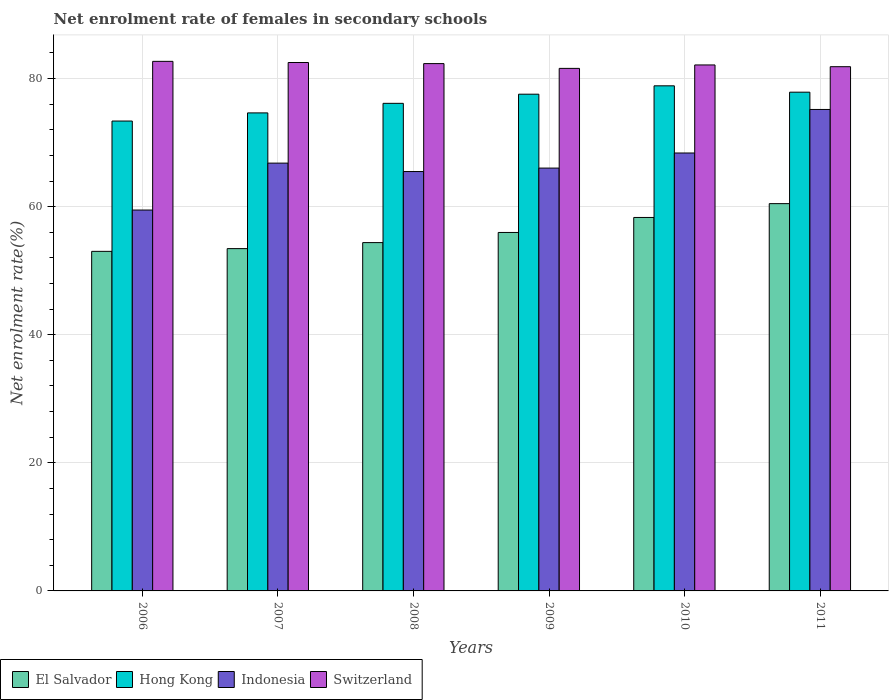How many different coloured bars are there?
Your answer should be compact. 4. How many bars are there on the 5th tick from the right?
Give a very brief answer. 4. What is the label of the 6th group of bars from the left?
Your answer should be very brief. 2011. In how many cases, is the number of bars for a given year not equal to the number of legend labels?
Make the answer very short. 0. What is the net enrolment rate of females in secondary schools in El Salvador in 2008?
Provide a succinct answer. 54.39. Across all years, what is the maximum net enrolment rate of females in secondary schools in El Salvador?
Give a very brief answer. 60.47. Across all years, what is the minimum net enrolment rate of females in secondary schools in Hong Kong?
Offer a terse response. 73.37. In which year was the net enrolment rate of females in secondary schools in Switzerland maximum?
Your answer should be very brief. 2006. In which year was the net enrolment rate of females in secondary schools in El Salvador minimum?
Your answer should be compact. 2006. What is the total net enrolment rate of females in secondary schools in Switzerland in the graph?
Ensure brevity in your answer.  493.08. What is the difference between the net enrolment rate of females in secondary schools in El Salvador in 2009 and that in 2011?
Provide a succinct answer. -4.5. What is the difference between the net enrolment rate of females in secondary schools in El Salvador in 2007 and the net enrolment rate of females in secondary schools in Hong Kong in 2009?
Your answer should be very brief. -24.11. What is the average net enrolment rate of females in secondary schools in Switzerland per year?
Offer a terse response. 82.18. In the year 2007, what is the difference between the net enrolment rate of females in secondary schools in Switzerland and net enrolment rate of females in secondary schools in El Salvador?
Offer a very short reply. 29.06. What is the ratio of the net enrolment rate of females in secondary schools in Indonesia in 2009 to that in 2010?
Your answer should be compact. 0.97. Is the net enrolment rate of females in secondary schools in Hong Kong in 2006 less than that in 2010?
Make the answer very short. Yes. What is the difference between the highest and the second highest net enrolment rate of females in secondary schools in Hong Kong?
Your answer should be compact. 0.99. What is the difference between the highest and the lowest net enrolment rate of females in secondary schools in Hong Kong?
Your answer should be compact. 5.5. In how many years, is the net enrolment rate of females in secondary schools in Switzerland greater than the average net enrolment rate of females in secondary schools in Switzerland taken over all years?
Your response must be concise. 3. Is the sum of the net enrolment rate of females in secondary schools in Hong Kong in 2006 and 2011 greater than the maximum net enrolment rate of females in secondary schools in Indonesia across all years?
Your answer should be compact. Yes. Is it the case that in every year, the sum of the net enrolment rate of females in secondary schools in Indonesia and net enrolment rate of females in secondary schools in Hong Kong is greater than the sum of net enrolment rate of females in secondary schools in Switzerland and net enrolment rate of females in secondary schools in El Salvador?
Keep it short and to the point. Yes. What does the 1st bar from the right in 2007 represents?
Offer a terse response. Switzerland. How many bars are there?
Ensure brevity in your answer.  24. Are all the bars in the graph horizontal?
Ensure brevity in your answer.  No. What is the difference between two consecutive major ticks on the Y-axis?
Provide a succinct answer. 20. Are the values on the major ticks of Y-axis written in scientific E-notation?
Your answer should be very brief. No. Does the graph contain any zero values?
Provide a succinct answer. No. Does the graph contain grids?
Ensure brevity in your answer.  Yes. What is the title of the graph?
Provide a short and direct response. Net enrolment rate of females in secondary schools. What is the label or title of the X-axis?
Your answer should be compact. Years. What is the label or title of the Y-axis?
Keep it short and to the point. Net enrolment rate(%). What is the Net enrolment rate(%) of El Salvador in 2006?
Your answer should be compact. 53.02. What is the Net enrolment rate(%) of Hong Kong in 2006?
Offer a terse response. 73.37. What is the Net enrolment rate(%) in Indonesia in 2006?
Provide a short and direct response. 59.47. What is the Net enrolment rate(%) in Switzerland in 2006?
Your answer should be very brief. 82.68. What is the Net enrolment rate(%) in El Salvador in 2007?
Provide a succinct answer. 53.44. What is the Net enrolment rate(%) in Hong Kong in 2007?
Your response must be concise. 74.64. What is the Net enrolment rate(%) in Indonesia in 2007?
Your response must be concise. 66.79. What is the Net enrolment rate(%) of Switzerland in 2007?
Your answer should be very brief. 82.5. What is the Net enrolment rate(%) in El Salvador in 2008?
Give a very brief answer. 54.39. What is the Net enrolment rate(%) of Hong Kong in 2008?
Offer a terse response. 76.13. What is the Net enrolment rate(%) in Indonesia in 2008?
Provide a short and direct response. 65.48. What is the Net enrolment rate(%) in Switzerland in 2008?
Your answer should be compact. 82.33. What is the Net enrolment rate(%) of El Salvador in 2009?
Your response must be concise. 55.97. What is the Net enrolment rate(%) in Hong Kong in 2009?
Offer a terse response. 77.56. What is the Net enrolment rate(%) of Indonesia in 2009?
Your answer should be very brief. 66.02. What is the Net enrolment rate(%) of Switzerland in 2009?
Offer a very short reply. 81.59. What is the Net enrolment rate(%) in El Salvador in 2010?
Provide a succinct answer. 58.31. What is the Net enrolment rate(%) of Hong Kong in 2010?
Offer a terse response. 78.86. What is the Net enrolment rate(%) in Indonesia in 2010?
Offer a very short reply. 68.38. What is the Net enrolment rate(%) of Switzerland in 2010?
Provide a short and direct response. 82.12. What is the Net enrolment rate(%) in El Salvador in 2011?
Ensure brevity in your answer.  60.47. What is the Net enrolment rate(%) of Hong Kong in 2011?
Your answer should be very brief. 77.87. What is the Net enrolment rate(%) of Indonesia in 2011?
Your answer should be compact. 75.17. What is the Net enrolment rate(%) in Switzerland in 2011?
Your response must be concise. 81.85. Across all years, what is the maximum Net enrolment rate(%) of El Salvador?
Offer a terse response. 60.47. Across all years, what is the maximum Net enrolment rate(%) of Hong Kong?
Offer a terse response. 78.86. Across all years, what is the maximum Net enrolment rate(%) in Indonesia?
Make the answer very short. 75.17. Across all years, what is the maximum Net enrolment rate(%) in Switzerland?
Give a very brief answer. 82.68. Across all years, what is the minimum Net enrolment rate(%) in El Salvador?
Your answer should be compact. 53.02. Across all years, what is the minimum Net enrolment rate(%) in Hong Kong?
Give a very brief answer. 73.37. Across all years, what is the minimum Net enrolment rate(%) in Indonesia?
Your answer should be very brief. 59.47. Across all years, what is the minimum Net enrolment rate(%) in Switzerland?
Give a very brief answer. 81.59. What is the total Net enrolment rate(%) in El Salvador in the graph?
Keep it short and to the point. 335.6. What is the total Net enrolment rate(%) of Hong Kong in the graph?
Your answer should be very brief. 458.43. What is the total Net enrolment rate(%) of Indonesia in the graph?
Your answer should be compact. 401.31. What is the total Net enrolment rate(%) of Switzerland in the graph?
Provide a short and direct response. 493.08. What is the difference between the Net enrolment rate(%) in El Salvador in 2006 and that in 2007?
Your answer should be compact. -0.42. What is the difference between the Net enrolment rate(%) of Hong Kong in 2006 and that in 2007?
Give a very brief answer. -1.27. What is the difference between the Net enrolment rate(%) in Indonesia in 2006 and that in 2007?
Offer a very short reply. -7.32. What is the difference between the Net enrolment rate(%) in Switzerland in 2006 and that in 2007?
Your answer should be compact. 0.18. What is the difference between the Net enrolment rate(%) of El Salvador in 2006 and that in 2008?
Ensure brevity in your answer.  -1.37. What is the difference between the Net enrolment rate(%) of Hong Kong in 2006 and that in 2008?
Provide a succinct answer. -2.76. What is the difference between the Net enrolment rate(%) in Indonesia in 2006 and that in 2008?
Your answer should be compact. -6.01. What is the difference between the Net enrolment rate(%) of Switzerland in 2006 and that in 2008?
Keep it short and to the point. 0.35. What is the difference between the Net enrolment rate(%) in El Salvador in 2006 and that in 2009?
Provide a short and direct response. -2.95. What is the difference between the Net enrolment rate(%) in Hong Kong in 2006 and that in 2009?
Your response must be concise. -4.19. What is the difference between the Net enrolment rate(%) in Indonesia in 2006 and that in 2009?
Offer a terse response. -6.55. What is the difference between the Net enrolment rate(%) in Switzerland in 2006 and that in 2009?
Provide a succinct answer. 1.1. What is the difference between the Net enrolment rate(%) of El Salvador in 2006 and that in 2010?
Offer a very short reply. -5.29. What is the difference between the Net enrolment rate(%) in Hong Kong in 2006 and that in 2010?
Your answer should be very brief. -5.5. What is the difference between the Net enrolment rate(%) of Indonesia in 2006 and that in 2010?
Give a very brief answer. -8.91. What is the difference between the Net enrolment rate(%) in Switzerland in 2006 and that in 2010?
Ensure brevity in your answer.  0.56. What is the difference between the Net enrolment rate(%) in El Salvador in 2006 and that in 2011?
Offer a terse response. -7.45. What is the difference between the Net enrolment rate(%) of Hong Kong in 2006 and that in 2011?
Your answer should be very brief. -4.5. What is the difference between the Net enrolment rate(%) of Indonesia in 2006 and that in 2011?
Your answer should be compact. -15.7. What is the difference between the Net enrolment rate(%) of Switzerland in 2006 and that in 2011?
Give a very brief answer. 0.83. What is the difference between the Net enrolment rate(%) in El Salvador in 2007 and that in 2008?
Give a very brief answer. -0.94. What is the difference between the Net enrolment rate(%) in Hong Kong in 2007 and that in 2008?
Make the answer very short. -1.49. What is the difference between the Net enrolment rate(%) in Indonesia in 2007 and that in 2008?
Make the answer very short. 1.31. What is the difference between the Net enrolment rate(%) in Switzerland in 2007 and that in 2008?
Offer a very short reply. 0.17. What is the difference between the Net enrolment rate(%) of El Salvador in 2007 and that in 2009?
Provide a short and direct response. -2.52. What is the difference between the Net enrolment rate(%) in Hong Kong in 2007 and that in 2009?
Make the answer very short. -2.92. What is the difference between the Net enrolment rate(%) of Indonesia in 2007 and that in 2009?
Offer a terse response. 0.78. What is the difference between the Net enrolment rate(%) in Switzerland in 2007 and that in 2009?
Make the answer very short. 0.92. What is the difference between the Net enrolment rate(%) of El Salvador in 2007 and that in 2010?
Keep it short and to the point. -4.87. What is the difference between the Net enrolment rate(%) of Hong Kong in 2007 and that in 2010?
Offer a very short reply. -4.23. What is the difference between the Net enrolment rate(%) of Indonesia in 2007 and that in 2010?
Offer a terse response. -1.58. What is the difference between the Net enrolment rate(%) of Switzerland in 2007 and that in 2010?
Make the answer very short. 0.38. What is the difference between the Net enrolment rate(%) in El Salvador in 2007 and that in 2011?
Keep it short and to the point. -7.02. What is the difference between the Net enrolment rate(%) in Hong Kong in 2007 and that in 2011?
Your answer should be compact. -3.23. What is the difference between the Net enrolment rate(%) in Indonesia in 2007 and that in 2011?
Offer a terse response. -8.38. What is the difference between the Net enrolment rate(%) of Switzerland in 2007 and that in 2011?
Offer a very short reply. 0.65. What is the difference between the Net enrolment rate(%) of El Salvador in 2008 and that in 2009?
Provide a short and direct response. -1.58. What is the difference between the Net enrolment rate(%) of Hong Kong in 2008 and that in 2009?
Your answer should be very brief. -1.43. What is the difference between the Net enrolment rate(%) of Indonesia in 2008 and that in 2009?
Your answer should be very brief. -0.54. What is the difference between the Net enrolment rate(%) in Switzerland in 2008 and that in 2009?
Your response must be concise. 0.75. What is the difference between the Net enrolment rate(%) of El Salvador in 2008 and that in 2010?
Your answer should be compact. -3.92. What is the difference between the Net enrolment rate(%) in Hong Kong in 2008 and that in 2010?
Provide a succinct answer. -2.73. What is the difference between the Net enrolment rate(%) in Indonesia in 2008 and that in 2010?
Your answer should be compact. -2.9. What is the difference between the Net enrolment rate(%) in Switzerland in 2008 and that in 2010?
Give a very brief answer. 0.21. What is the difference between the Net enrolment rate(%) of El Salvador in 2008 and that in 2011?
Give a very brief answer. -6.08. What is the difference between the Net enrolment rate(%) in Hong Kong in 2008 and that in 2011?
Provide a succinct answer. -1.74. What is the difference between the Net enrolment rate(%) of Indonesia in 2008 and that in 2011?
Keep it short and to the point. -9.69. What is the difference between the Net enrolment rate(%) of Switzerland in 2008 and that in 2011?
Give a very brief answer. 0.48. What is the difference between the Net enrolment rate(%) of El Salvador in 2009 and that in 2010?
Give a very brief answer. -2.34. What is the difference between the Net enrolment rate(%) in Hong Kong in 2009 and that in 2010?
Make the answer very short. -1.31. What is the difference between the Net enrolment rate(%) in Indonesia in 2009 and that in 2010?
Offer a very short reply. -2.36. What is the difference between the Net enrolment rate(%) of Switzerland in 2009 and that in 2010?
Your response must be concise. -0.54. What is the difference between the Net enrolment rate(%) in El Salvador in 2009 and that in 2011?
Your answer should be compact. -4.5. What is the difference between the Net enrolment rate(%) in Hong Kong in 2009 and that in 2011?
Make the answer very short. -0.31. What is the difference between the Net enrolment rate(%) in Indonesia in 2009 and that in 2011?
Keep it short and to the point. -9.15. What is the difference between the Net enrolment rate(%) in Switzerland in 2009 and that in 2011?
Keep it short and to the point. -0.26. What is the difference between the Net enrolment rate(%) of El Salvador in 2010 and that in 2011?
Your answer should be compact. -2.16. What is the difference between the Net enrolment rate(%) of Hong Kong in 2010 and that in 2011?
Your answer should be very brief. 0.99. What is the difference between the Net enrolment rate(%) of Indonesia in 2010 and that in 2011?
Your response must be concise. -6.8. What is the difference between the Net enrolment rate(%) of Switzerland in 2010 and that in 2011?
Ensure brevity in your answer.  0.27. What is the difference between the Net enrolment rate(%) of El Salvador in 2006 and the Net enrolment rate(%) of Hong Kong in 2007?
Ensure brevity in your answer.  -21.62. What is the difference between the Net enrolment rate(%) of El Salvador in 2006 and the Net enrolment rate(%) of Indonesia in 2007?
Ensure brevity in your answer.  -13.77. What is the difference between the Net enrolment rate(%) of El Salvador in 2006 and the Net enrolment rate(%) of Switzerland in 2007?
Your answer should be very brief. -29.48. What is the difference between the Net enrolment rate(%) of Hong Kong in 2006 and the Net enrolment rate(%) of Indonesia in 2007?
Keep it short and to the point. 6.57. What is the difference between the Net enrolment rate(%) in Hong Kong in 2006 and the Net enrolment rate(%) in Switzerland in 2007?
Keep it short and to the point. -9.14. What is the difference between the Net enrolment rate(%) in Indonesia in 2006 and the Net enrolment rate(%) in Switzerland in 2007?
Provide a succinct answer. -23.03. What is the difference between the Net enrolment rate(%) in El Salvador in 2006 and the Net enrolment rate(%) in Hong Kong in 2008?
Offer a very short reply. -23.11. What is the difference between the Net enrolment rate(%) of El Salvador in 2006 and the Net enrolment rate(%) of Indonesia in 2008?
Your response must be concise. -12.46. What is the difference between the Net enrolment rate(%) of El Salvador in 2006 and the Net enrolment rate(%) of Switzerland in 2008?
Your response must be concise. -29.31. What is the difference between the Net enrolment rate(%) of Hong Kong in 2006 and the Net enrolment rate(%) of Indonesia in 2008?
Keep it short and to the point. 7.89. What is the difference between the Net enrolment rate(%) of Hong Kong in 2006 and the Net enrolment rate(%) of Switzerland in 2008?
Offer a terse response. -8.97. What is the difference between the Net enrolment rate(%) of Indonesia in 2006 and the Net enrolment rate(%) of Switzerland in 2008?
Offer a very short reply. -22.86. What is the difference between the Net enrolment rate(%) of El Salvador in 2006 and the Net enrolment rate(%) of Hong Kong in 2009?
Provide a short and direct response. -24.54. What is the difference between the Net enrolment rate(%) in El Salvador in 2006 and the Net enrolment rate(%) in Indonesia in 2009?
Offer a very short reply. -13. What is the difference between the Net enrolment rate(%) in El Salvador in 2006 and the Net enrolment rate(%) in Switzerland in 2009?
Ensure brevity in your answer.  -28.57. What is the difference between the Net enrolment rate(%) in Hong Kong in 2006 and the Net enrolment rate(%) in Indonesia in 2009?
Offer a very short reply. 7.35. What is the difference between the Net enrolment rate(%) of Hong Kong in 2006 and the Net enrolment rate(%) of Switzerland in 2009?
Provide a succinct answer. -8.22. What is the difference between the Net enrolment rate(%) of Indonesia in 2006 and the Net enrolment rate(%) of Switzerland in 2009?
Give a very brief answer. -22.12. What is the difference between the Net enrolment rate(%) of El Salvador in 2006 and the Net enrolment rate(%) of Hong Kong in 2010?
Your response must be concise. -25.84. What is the difference between the Net enrolment rate(%) of El Salvador in 2006 and the Net enrolment rate(%) of Indonesia in 2010?
Give a very brief answer. -15.36. What is the difference between the Net enrolment rate(%) of El Salvador in 2006 and the Net enrolment rate(%) of Switzerland in 2010?
Provide a succinct answer. -29.1. What is the difference between the Net enrolment rate(%) in Hong Kong in 2006 and the Net enrolment rate(%) in Indonesia in 2010?
Your answer should be compact. 4.99. What is the difference between the Net enrolment rate(%) of Hong Kong in 2006 and the Net enrolment rate(%) of Switzerland in 2010?
Offer a very short reply. -8.76. What is the difference between the Net enrolment rate(%) of Indonesia in 2006 and the Net enrolment rate(%) of Switzerland in 2010?
Your answer should be very brief. -22.65. What is the difference between the Net enrolment rate(%) of El Salvador in 2006 and the Net enrolment rate(%) of Hong Kong in 2011?
Keep it short and to the point. -24.85. What is the difference between the Net enrolment rate(%) of El Salvador in 2006 and the Net enrolment rate(%) of Indonesia in 2011?
Ensure brevity in your answer.  -22.15. What is the difference between the Net enrolment rate(%) in El Salvador in 2006 and the Net enrolment rate(%) in Switzerland in 2011?
Make the answer very short. -28.83. What is the difference between the Net enrolment rate(%) of Hong Kong in 2006 and the Net enrolment rate(%) of Indonesia in 2011?
Make the answer very short. -1.81. What is the difference between the Net enrolment rate(%) of Hong Kong in 2006 and the Net enrolment rate(%) of Switzerland in 2011?
Your response must be concise. -8.48. What is the difference between the Net enrolment rate(%) of Indonesia in 2006 and the Net enrolment rate(%) of Switzerland in 2011?
Your answer should be very brief. -22.38. What is the difference between the Net enrolment rate(%) in El Salvador in 2007 and the Net enrolment rate(%) in Hong Kong in 2008?
Offer a terse response. -22.68. What is the difference between the Net enrolment rate(%) of El Salvador in 2007 and the Net enrolment rate(%) of Indonesia in 2008?
Offer a terse response. -12.04. What is the difference between the Net enrolment rate(%) of El Salvador in 2007 and the Net enrolment rate(%) of Switzerland in 2008?
Your answer should be very brief. -28.89. What is the difference between the Net enrolment rate(%) of Hong Kong in 2007 and the Net enrolment rate(%) of Indonesia in 2008?
Make the answer very short. 9.16. What is the difference between the Net enrolment rate(%) in Hong Kong in 2007 and the Net enrolment rate(%) in Switzerland in 2008?
Your response must be concise. -7.7. What is the difference between the Net enrolment rate(%) in Indonesia in 2007 and the Net enrolment rate(%) in Switzerland in 2008?
Provide a succinct answer. -15.54. What is the difference between the Net enrolment rate(%) in El Salvador in 2007 and the Net enrolment rate(%) in Hong Kong in 2009?
Your answer should be compact. -24.11. What is the difference between the Net enrolment rate(%) of El Salvador in 2007 and the Net enrolment rate(%) of Indonesia in 2009?
Your answer should be very brief. -12.57. What is the difference between the Net enrolment rate(%) of El Salvador in 2007 and the Net enrolment rate(%) of Switzerland in 2009?
Ensure brevity in your answer.  -28.14. What is the difference between the Net enrolment rate(%) of Hong Kong in 2007 and the Net enrolment rate(%) of Indonesia in 2009?
Your response must be concise. 8.62. What is the difference between the Net enrolment rate(%) in Hong Kong in 2007 and the Net enrolment rate(%) in Switzerland in 2009?
Make the answer very short. -6.95. What is the difference between the Net enrolment rate(%) of Indonesia in 2007 and the Net enrolment rate(%) of Switzerland in 2009?
Ensure brevity in your answer.  -14.79. What is the difference between the Net enrolment rate(%) of El Salvador in 2007 and the Net enrolment rate(%) of Hong Kong in 2010?
Make the answer very short. -25.42. What is the difference between the Net enrolment rate(%) of El Salvador in 2007 and the Net enrolment rate(%) of Indonesia in 2010?
Your response must be concise. -14.93. What is the difference between the Net enrolment rate(%) of El Salvador in 2007 and the Net enrolment rate(%) of Switzerland in 2010?
Offer a terse response. -28.68. What is the difference between the Net enrolment rate(%) of Hong Kong in 2007 and the Net enrolment rate(%) of Indonesia in 2010?
Offer a very short reply. 6.26. What is the difference between the Net enrolment rate(%) of Hong Kong in 2007 and the Net enrolment rate(%) of Switzerland in 2010?
Provide a succinct answer. -7.49. What is the difference between the Net enrolment rate(%) of Indonesia in 2007 and the Net enrolment rate(%) of Switzerland in 2010?
Your answer should be compact. -15.33. What is the difference between the Net enrolment rate(%) in El Salvador in 2007 and the Net enrolment rate(%) in Hong Kong in 2011?
Offer a very short reply. -24.43. What is the difference between the Net enrolment rate(%) in El Salvador in 2007 and the Net enrolment rate(%) in Indonesia in 2011?
Offer a terse response. -21.73. What is the difference between the Net enrolment rate(%) of El Salvador in 2007 and the Net enrolment rate(%) of Switzerland in 2011?
Offer a very short reply. -28.41. What is the difference between the Net enrolment rate(%) of Hong Kong in 2007 and the Net enrolment rate(%) of Indonesia in 2011?
Your answer should be compact. -0.54. What is the difference between the Net enrolment rate(%) in Hong Kong in 2007 and the Net enrolment rate(%) in Switzerland in 2011?
Give a very brief answer. -7.21. What is the difference between the Net enrolment rate(%) in Indonesia in 2007 and the Net enrolment rate(%) in Switzerland in 2011?
Your answer should be very brief. -15.06. What is the difference between the Net enrolment rate(%) of El Salvador in 2008 and the Net enrolment rate(%) of Hong Kong in 2009?
Your answer should be very brief. -23.17. What is the difference between the Net enrolment rate(%) in El Salvador in 2008 and the Net enrolment rate(%) in Indonesia in 2009?
Your answer should be very brief. -11.63. What is the difference between the Net enrolment rate(%) in El Salvador in 2008 and the Net enrolment rate(%) in Switzerland in 2009?
Provide a succinct answer. -27.2. What is the difference between the Net enrolment rate(%) in Hong Kong in 2008 and the Net enrolment rate(%) in Indonesia in 2009?
Offer a terse response. 10.11. What is the difference between the Net enrolment rate(%) in Hong Kong in 2008 and the Net enrolment rate(%) in Switzerland in 2009?
Give a very brief answer. -5.46. What is the difference between the Net enrolment rate(%) in Indonesia in 2008 and the Net enrolment rate(%) in Switzerland in 2009?
Your response must be concise. -16.11. What is the difference between the Net enrolment rate(%) in El Salvador in 2008 and the Net enrolment rate(%) in Hong Kong in 2010?
Provide a short and direct response. -24.48. What is the difference between the Net enrolment rate(%) of El Salvador in 2008 and the Net enrolment rate(%) of Indonesia in 2010?
Your answer should be very brief. -13.99. What is the difference between the Net enrolment rate(%) in El Salvador in 2008 and the Net enrolment rate(%) in Switzerland in 2010?
Offer a terse response. -27.74. What is the difference between the Net enrolment rate(%) of Hong Kong in 2008 and the Net enrolment rate(%) of Indonesia in 2010?
Your answer should be compact. 7.75. What is the difference between the Net enrolment rate(%) of Hong Kong in 2008 and the Net enrolment rate(%) of Switzerland in 2010?
Give a very brief answer. -5.99. What is the difference between the Net enrolment rate(%) of Indonesia in 2008 and the Net enrolment rate(%) of Switzerland in 2010?
Ensure brevity in your answer.  -16.64. What is the difference between the Net enrolment rate(%) of El Salvador in 2008 and the Net enrolment rate(%) of Hong Kong in 2011?
Make the answer very short. -23.49. What is the difference between the Net enrolment rate(%) in El Salvador in 2008 and the Net enrolment rate(%) in Indonesia in 2011?
Your answer should be compact. -20.79. What is the difference between the Net enrolment rate(%) of El Salvador in 2008 and the Net enrolment rate(%) of Switzerland in 2011?
Your response must be concise. -27.46. What is the difference between the Net enrolment rate(%) of Hong Kong in 2008 and the Net enrolment rate(%) of Indonesia in 2011?
Offer a terse response. 0.96. What is the difference between the Net enrolment rate(%) in Hong Kong in 2008 and the Net enrolment rate(%) in Switzerland in 2011?
Your response must be concise. -5.72. What is the difference between the Net enrolment rate(%) of Indonesia in 2008 and the Net enrolment rate(%) of Switzerland in 2011?
Give a very brief answer. -16.37. What is the difference between the Net enrolment rate(%) in El Salvador in 2009 and the Net enrolment rate(%) in Hong Kong in 2010?
Your response must be concise. -22.9. What is the difference between the Net enrolment rate(%) of El Salvador in 2009 and the Net enrolment rate(%) of Indonesia in 2010?
Your answer should be compact. -12.41. What is the difference between the Net enrolment rate(%) of El Salvador in 2009 and the Net enrolment rate(%) of Switzerland in 2010?
Make the answer very short. -26.15. What is the difference between the Net enrolment rate(%) in Hong Kong in 2009 and the Net enrolment rate(%) in Indonesia in 2010?
Your response must be concise. 9.18. What is the difference between the Net enrolment rate(%) in Hong Kong in 2009 and the Net enrolment rate(%) in Switzerland in 2010?
Make the answer very short. -4.57. What is the difference between the Net enrolment rate(%) of Indonesia in 2009 and the Net enrolment rate(%) of Switzerland in 2010?
Provide a succinct answer. -16.1. What is the difference between the Net enrolment rate(%) of El Salvador in 2009 and the Net enrolment rate(%) of Hong Kong in 2011?
Offer a very short reply. -21.9. What is the difference between the Net enrolment rate(%) of El Salvador in 2009 and the Net enrolment rate(%) of Indonesia in 2011?
Provide a succinct answer. -19.2. What is the difference between the Net enrolment rate(%) in El Salvador in 2009 and the Net enrolment rate(%) in Switzerland in 2011?
Make the answer very short. -25.88. What is the difference between the Net enrolment rate(%) in Hong Kong in 2009 and the Net enrolment rate(%) in Indonesia in 2011?
Keep it short and to the point. 2.38. What is the difference between the Net enrolment rate(%) in Hong Kong in 2009 and the Net enrolment rate(%) in Switzerland in 2011?
Your answer should be very brief. -4.29. What is the difference between the Net enrolment rate(%) in Indonesia in 2009 and the Net enrolment rate(%) in Switzerland in 2011?
Your answer should be compact. -15.83. What is the difference between the Net enrolment rate(%) in El Salvador in 2010 and the Net enrolment rate(%) in Hong Kong in 2011?
Keep it short and to the point. -19.56. What is the difference between the Net enrolment rate(%) of El Salvador in 2010 and the Net enrolment rate(%) of Indonesia in 2011?
Provide a short and direct response. -16.86. What is the difference between the Net enrolment rate(%) of El Salvador in 2010 and the Net enrolment rate(%) of Switzerland in 2011?
Your answer should be compact. -23.54. What is the difference between the Net enrolment rate(%) of Hong Kong in 2010 and the Net enrolment rate(%) of Indonesia in 2011?
Make the answer very short. 3.69. What is the difference between the Net enrolment rate(%) of Hong Kong in 2010 and the Net enrolment rate(%) of Switzerland in 2011?
Offer a very short reply. -2.99. What is the difference between the Net enrolment rate(%) of Indonesia in 2010 and the Net enrolment rate(%) of Switzerland in 2011?
Your answer should be compact. -13.47. What is the average Net enrolment rate(%) in El Salvador per year?
Ensure brevity in your answer.  55.93. What is the average Net enrolment rate(%) of Hong Kong per year?
Your response must be concise. 76.4. What is the average Net enrolment rate(%) of Indonesia per year?
Offer a terse response. 66.89. What is the average Net enrolment rate(%) of Switzerland per year?
Keep it short and to the point. 82.18. In the year 2006, what is the difference between the Net enrolment rate(%) of El Salvador and Net enrolment rate(%) of Hong Kong?
Offer a terse response. -20.35. In the year 2006, what is the difference between the Net enrolment rate(%) of El Salvador and Net enrolment rate(%) of Indonesia?
Keep it short and to the point. -6.45. In the year 2006, what is the difference between the Net enrolment rate(%) of El Salvador and Net enrolment rate(%) of Switzerland?
Make the answer very short. -29.66. In the year 2006, what is the difference between the Net enrolment rate(%) of Hong Kong and Net enrolment rate(%) of Indonesia?
Offer a terse response. 13.9. In the year 2006, what is the difference between the Net enrolment rate(%) of Hong Kong and Net enrolment rate(%) of Switzerland?
Give a very brief answer. -9.32. In the year 2006, what is the difference between the Net enrolment rate(%) of Indonesia and Net enrolment rate(%) of Switzerland?
Your answer should be very brief. -23.21. In the year 2007, what is the difference between the Net enrolment rate(%) of El Salvador and Net enrolment rate(%) of Hong Kong?
Your answer should be very brief. -21.19. In the year 2007, what is the difference between the Net enrolment rate(%) in El Salvador and Net enrolment rate(%) in Indonesia?
Make the answer very short. -13.35. In the year 2007, what is the difference between the Net enrolment rate(%) of El Salvador and Net enrolment rate(%) of Switzerland?
Provide a succinct answer. -29.06. In the year 2007, what is the difference between the Net enrolment rate(%) of Hong Kong and Net enrolment rate(%) of Indonesia?
Ensure brevity in your answer.  7.84. In the year 2007, what is the difference between the Net enrolment rate(%) in Hong Kong and Net enrolment rate(%) in Switzerland?
Offer a terse response. -7.87. In the year 2007, what is the difference between the Net enrolment rate(%) in Indonesia and Net enrolment rate(%) in Switzerland?
Provide a short and direct response. -15.71. In the year 2008, what is the difference between the Net enrolment rate(%) of El Salvador and Net enrolment rate(%) of Hong Kong?
Make the answer very short. -21.74. In the year 2008, what is the difference between the Net enrolment rate(%) in El Salvador and Net enrolment rate(%) in Indonesia?
Ensure brevity in your answer.  -11.09. In the year 2008, what is the difference between the Net enrolment rate(%) of El Salvador and Net enrolment rate(%) of Switzerland?
Keep it short and to the point. -27.95. In the year 2008, what is the difference between the Net enrolment rate(%) of Hong Kong and Net enrolment rate(%) of Indonesia?
Your response must be concise. 10.65. In the year 2008, what is the difference between the Net enrolment rate(%) of Hong Kong and Net enrolment rate(%) of Switzerland?
Provide a succinct answer. -6.2. In the year 2008, what is the difference between the Net enrolment rate(%) in Indonesia and Net enrolment rate(%) in Switzerland?
Provide a succinct answer. -16.85. In the year 2009, what is the difference between the Net enrolment rate(%) in El Salvador and Net enrolment rate(%) in Hong Kong?
Your response must be concise. -21.59. In the year 2009, what is the difference between the Net enrolment rate(%) in El Salvador and Net enrolment rate(%) in Indonesia?
Your answer should be very brief. -10.05. In the year 2009, what is the difference between the Net enrolment rate(%) of El Salvador and Net enrolment rate(%) of Switzerland?
Your answer should be compact. -25.62. In the year 2009, what is the difference between the Net enrolment rate(%) of Hong Kong and Net enrolment rate(%) of Indonesia?
Provide a short and direct response. 11.54. In the year 2009, what is the difference between the Net enrolment rate(%) of Hong Kong and Net enrolment rate(%) of Switzerland?
Your answer should be very brief. -4.03. In the year 2009, what is the difference between the Net enrolment rate(%) of Indonesia and Net enrolment rate(%) of Switzerland?
Your answer should be compact. -15.57. In the year 2010, what is the difference between the Net enrolment rate(%) in El Salvador and Net enrolment rate(%) in Hong Kong?
Provide a short and direct response. -20.55. In the year 2010, what is the difference between the Net enrolment rate(%) of El Salvador and Net enrolment rate(%) of Indonesia?
Provide a short and direct response. -10.07. In the year 2010, what is the difference between the Net enrolment rate(%) in El Salvador and Net enrolment rate(%) in Switzerland?
Keep it short and to the point. -23.81. In the year 2010, what is the difference between the Net enrolment rate(%) in Hong Kong and Net enrolment rate(%) in Indonesia?
Provide a succinct answer. 10.49. In the year 2010, what is the difference between the Net enrolment rate(%) in Hong Kong and Net enrolment rate(%) in Switzerland?
Provide a succinct answer. -3.26. In the year 2010, what is the difference between the Net enrolment rate(%) of Indonesia and Net enrolment rate(%) of Switzerland?
Ensure brevity in your answer.  -13.75. In the year 2011, what is the difference between the Net enrolment rate(%) of El Salvador and Net enrolment rate(%) of Hong Kong?
Offer a terse response. -17.4. In the year 2011, what is the difference between the Net enrolment rate(%) in El Salvador and Net enrolment rate(%) in Indonesia?
Your answer should be very brief. -14.7. In the year 2011, what is the difference between the Net enrolment rate(%) in El Salvador and Net enrolment rate(%) in Switzerland?
Give a very brief answer. -21.38. In the year 2011, what is the difference between the Net enrolment rate(%) of Hong Kong and Net enrolment rate(%) of Indonesia?
Your response must be concise. 2.7. In the year 2011, what is the difference between the Net enrolment rate(%) in Hong Kong and Net enrolment rate(%) in Switzerland?
Your answer should be very brief. -3.98. In the year 2011, what is the difference between the Net enrolment rate(%) in Indonesia and Net enrolment rate(%) in Switzerland?
Your answer should be compact. -6.68. What is the ratio of the Net enrolment rate(%) in El Salvador in 2006 to that in 2007?
Make the answer very short. 0.99. What is the ratio of the Net enrolment rate(%) of Indonesia in 2006 to that in 2007?
Your answer should be compact. 0.89. What is the ratio of the Net enrolment rate(%) of Switzerland in 2006 to that in 2007?
Provide a short and direct response. 1. What is the ratio of the Net enrolment rate(%) in El Salvador in 2006 to that in 2008?
Provide a short and direct response. 0.97. What is the ratio of the Net enrolment rate(%) in Hong Kong in 2006 to that in 2008?
Ensure brevity in your answer.  0.96. What is the ratio of the Net enrolment rate(%) of Indonesia in 2006 to that in 2008?
Provide a short and direct response. 0.91. What is the ratio of the Net enrolment rate(%) in Switzerland in 2006 to that in 2008?
Give a very brief answer. 1. What is the ratio of the Net enrolment rate(%) of El Salvador in 2006 to that in 2009?
Keep it short and to the point. 0.95. What is the ratio of the Net enrolment rate(%) in Hong Kong in 2006 to that in 2009?
Make the answer very short. 0.95. What is the ratio of the Net enrolment rate(%) of Indonesia in 2006 to that in 2009?
Give a very brief answer. 0.9. What is the ratio of the Net enrolment rate(%) of Switzerland in 2006 to that in 2009?
Offer a terse response. 1.01. What is the ratio of the Net enrolment rate(%) of El Salvador in 2006 to that in 2010?
Offer a terse response. 0.91. What is the ratio of the Net enrolment rate(%) of Hong Kong in 2006 to that in 2010?
Make the answer very short. 0.93. What is the ratio of the Net enrolment rate(%) of Indonesia in 2006 to that in 2010?
Offer a terse response. 0.87. What is the ratio of the Net enrolment rate(%) of Switzerland in 2006 to that in 2010?
Offer a terse response. 1.01. What is the ratio of the Net enrolment rate(%) of El Salvador in 2006 to that in 2011?
Your answer should be very brief. 0.88. What is the ratio of the Net enrolment rate(%) of Hong Kong in 2006 to that in 2011?
Make the answer very short. 0.94. What is the ratio of the Net enrolment rate(%) of Indonesia in 2006 to that in 2011?
Make the answer very short. 0.79. What is the ratio of the Net enrolment rate(%) in Switzerland in 2006 to that in 2011?
Your answer should be very brief. 1.01. What is the ratio of the Net enrolment rate(%) of El Salvador in 2007 to that in 2008?
Ensure brevity in your answer.  0.98. What is the ratio of the Net enrolment rate(%) of Hong Kong in 2007 to that in 2008?
Provide a succinct answer. 0.98. What is the ratio of the Net enrolment rate(%) in Indonesia in 2007 to that in 2008?
Provide a succinct answer. 1.02. What is the ratio of the Net enrolment rate(%) of El Salvador in 2007 to that in 2009?
Keep it short and to the point. 0.95. What is the ratio of the Net enrolment rate(%) in Hong Kong in 2007 to that in 2009?
Your answer should be very brief. 0.96. What is the ratio of the Net enrolment rate(%) of Indonesia in 2007 to that in 2009?
Make the answer very short. 1.01. What is the ratio of the Net enrolment rate(%) in Switzerland in 2007 to that in 2009?
Make the answer very short. 1.01. What is the ratio of the Net enrolment rate(%) of El Salvador in 2007 to that in 2010?
Your answer should be very brief. 0.92. What is the ratio of the Net enrolment rate(%) in Hong Kong in 2007 to that in 2010?
Keep it short and to the point. 0.95. What is the ratio of the Net enrolment rate(%) of Indonesia in 2007 to that in 2010?
Your response must be concise. 0.98. What is the ratio of the Net enrolment rate(%) of El Salvador in 2007 to that in 2011?
Your response must be concise. 0.88. What is the ratio of the Net enrolment rate(%) in Hong Kong in 2007 to that in 2011?
Your answer should be very brief. 0.96. What is the ratio of the Net enrolment rate(%) in Indonesia in 2007 to that in 2011?
Ensure brevity in your answer.  0.89. What is the ratio of the Net enrolment rate(%) in Switzerland in 2007 to that in 2011?
Your response must be concise. 1.01. What is the ratio of the Net enrolment rate(%) of El Salvador in 2008 to that in 2009?
Offer a terse response. 0.97. What is the ratio of the Net enrolment rate(%) in Hong Kong in 2008 to that in 2009?
Give a very brief answer. 0.98. What is the ratio of the Net enrolment rate(%) of Indonesia in 2008 to that in 2009?
Keep it short and to the point. 0.99. What is the ratio of the Net enrolment rate(%) in Switzerland in 2008 to that in 2009?
Offer a very short reply. 1.01. What is the ratio of the Net enrolment rate(%) in El Salvador in 2008 to that in 2010?
Offer a very short reply. 0.93. What is the ratio of the Net enrolment rate(%) in Hong Kong in 2008 to that in 2010?
Offer a very short reply. 0.97. What is the ratio of the Net enrolment rate(%) in Indonesia in 2008 to that in 2010?
Offer a very short reply. 0.96. What is the ratio of the Net enrolment rate(%) in El Salvador in 2008 to that in 2011?
Give a very brief answer. 0.9. What is the ratio of the Net enrolment rate(%) of Hong Kong in 2008 to that in 2011?
Provide a succinct answer. 0.98. What is the ratio of the Net enrolment rate(%) of Indonesia in 2008 to that in 2011?
Give a very brief answer. 0.87. What is the ratio of the Net enrolment rate(%) of Switzerland in 2008 to that in 2011?
Provide a short and direct response. 1.01. What is the ratio of the Net enrolment rate(%) in El Salvador in 2009 to that in 2010?
Give a very brief answer. 0.96. What is the ratio of the Net enrolment rate(%) of Hong Kong in 2009 to that in 2010?
Your response must be concise. 0.98. What is the ratio of the Net enrolment rate(%) in Indonesia in 2009 to that in 2010?
Your answer should be compact. 0.97. What is the ratio of the Net enrolment rate(%) in Switzerland in 2009 to that in 2010?
Ensure brevity in your answer.  0.99. What is the ratio of the Net enrolment rate(%) of El Salvador in 2009 to that in 2011?
Provide a succinct answer. 0.93. What is the ratio of the Net enrolment rate(%) of Indonesia in 2009 to that in 2011?
Offer a very short reply. 0.88. What is the ratio of the Net enrolment rate(%) in Hong Kong in 2010 to that in 2011?
Give a very brief answer. 1.01. What is the ratio of the Net enrolment rate(%) in Indonesia in 2010 to that in 2011?
Your answer should be compact. 0.91. What is the difference between the highest and the second highest Net enrolment rate(%) in El Salvador?
Your response must be concise. 2.16. What is the difference between the highest and the second highest Net enrolment rate(%) in Indonesia?
Provide a succinct answer. 6.8. What is the difference between the highest and the second highest Net enrolment rate(%) of Switzerland?
Your answer should be compact. 0.18. What is the difference between the highest and the lowest Net enrolment rate(%) in El Salvador?
Provide a short and direct response. 7.45. What is the difference between the highest and the lowest Net enrolment rate(%) in Hong Kong?
Make the answer very short. 5.5. What is the difference between the highest and the lowest Net enrolment rate(%) of Indonesia?
Provide a succinct answer. 15.7. What is the difference between the highest and the lowest Net enrolment rate(%) of Switzerland?
Ensure brevity in your answer.  1.1. 